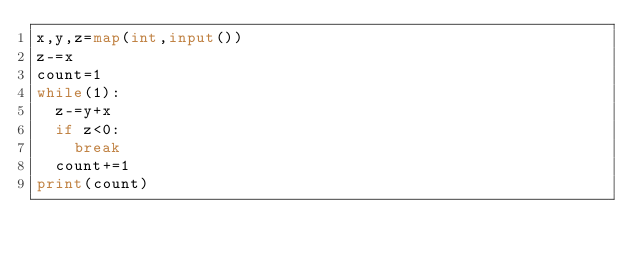<code> <loc_0><loc_0><loc_500><loc_500><_Python_>x,y,z=map(int,input())
z-=x
count=1
while(1):
  z-=y+x
  if z<0:
    break
  count+=1
print(count)</code> 